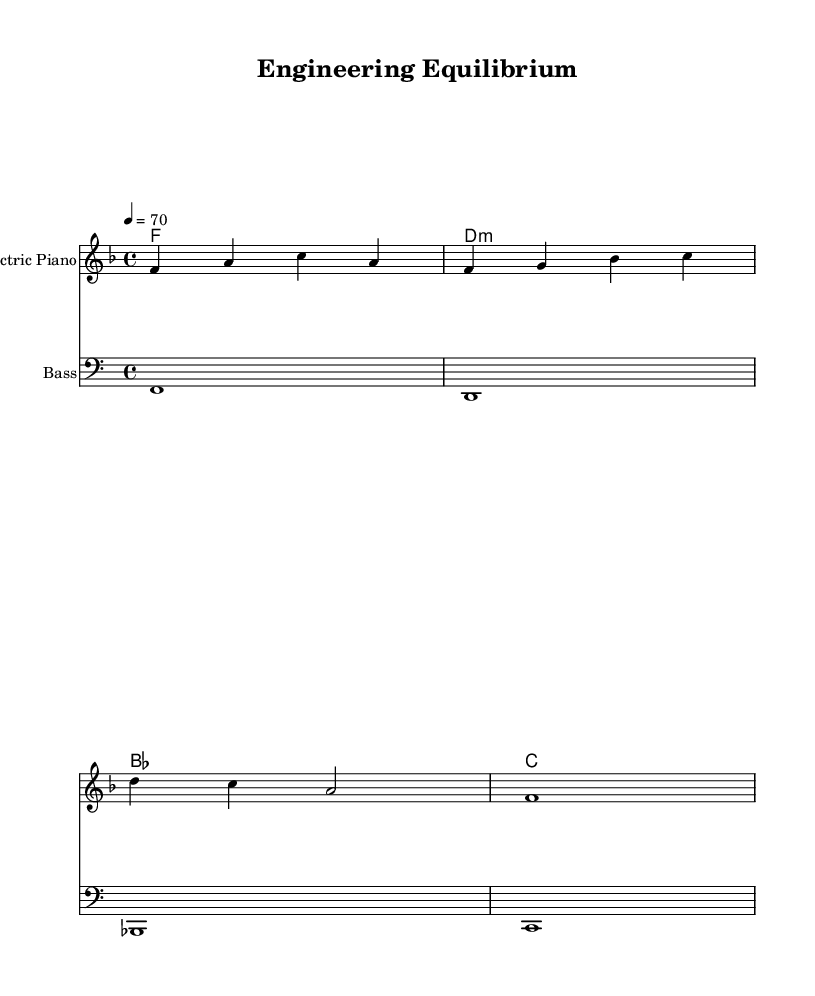What is the key signature of this music? The key signature, indicated by the absence of any sharps or flats on the staff, corresponds to F major, which has one flat (B flat).
Answer: F major What is the time signature of this music? The time signature appears at the beginning of the score as 4/4, which indicates four beats per measure.
Answer: 4/4 What is the tempo marking for this piece? The tempo marking is indicated at the beginning as "4 = 70," which defines the speed of the music, revealing that there are 70 quarter note beats per minute.
Answer: 70 What instruments are used in this piece? The instruments are identified in the score; the first staff is for "Electric Piano," and the second staff is for "Bass."
Answer: Electric Piano, Bass How many measures are there in the melody? The melody has four measures, as indicated by the division of the music within the bar lines, each representing a measure.
Answer: 4 What type of chord appears in the harmonies? The harmonies consist of F major and D minor, indicated by the chord symbols, which are standard in the context of the music's genre.
Answer: F major, D minor What theme does this music likely explore? The music's title "Engineering Equilibrium" suggests themes that balance between work and relaxation, which is often characteristic of the soul genre.
Answer: Balance between work and relaxation 